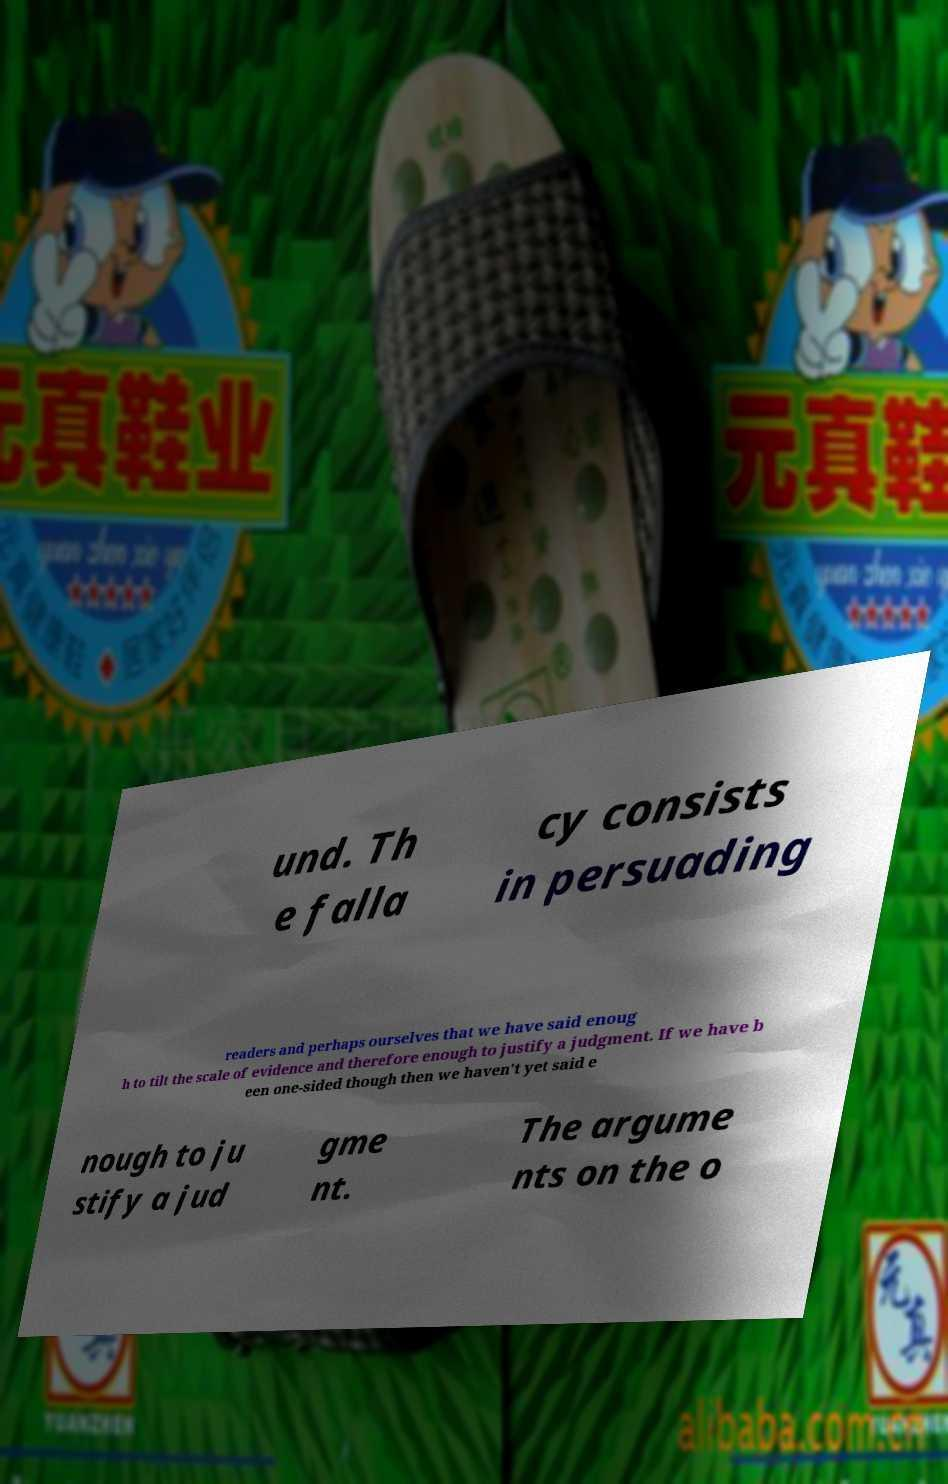I need the written content from this picture converted into text. Can you do that? und. Th e falla cy consists in persuading readers and perhaps ourselves that we have said enoug h to tilt the scale of evidence and therefore enough to justify a judgment. If we have b een one-sided though then we haven't yet said e nough to ju stify a jud gme nt. The argume nts on the o 